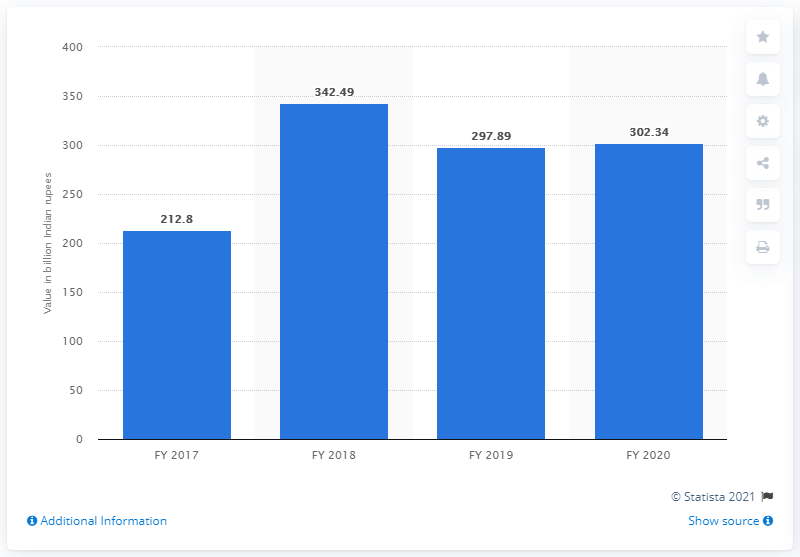Outline some significant characteristics in this image. Axis Bank's gross non-performing assets in fiscal year 2020 were 302.34 Indian rupees. In fiscal year 2020, the value of gross non-performing assets at Axis Bank was 342.49. The year with the highest number is 2018. The average of the first, second, and third highest values in the blue bar is 314.24. 